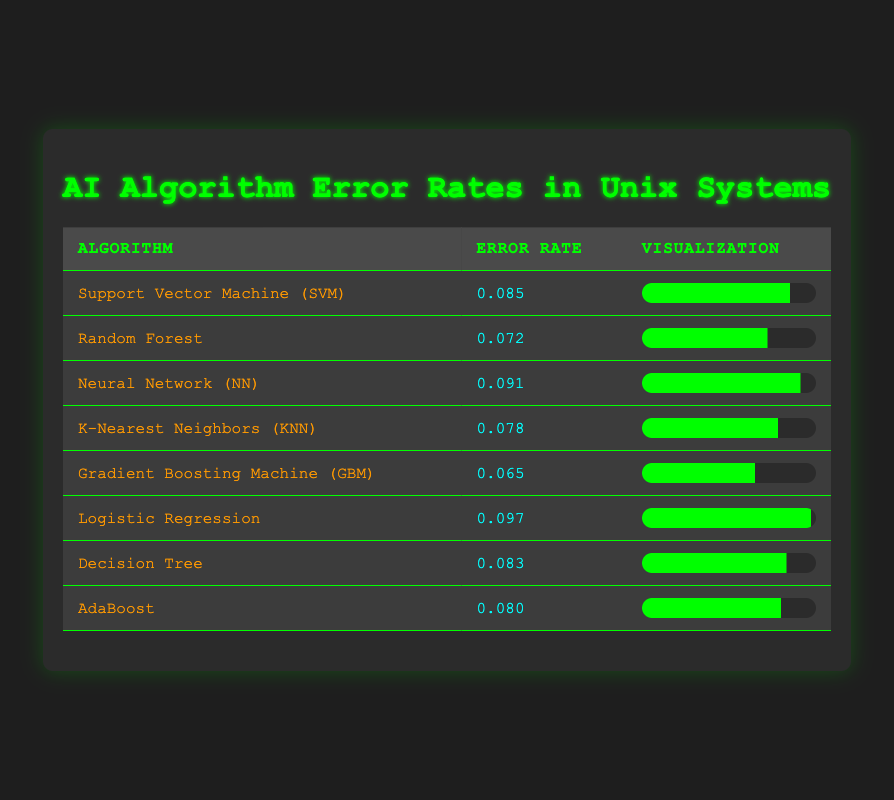What is the error rate of the Random Forest algorithm? The Random Forest algorithm is listed in the table along with its corresponding error rate, which is recorded as 0.072.
Answer: 0.072 Which algorithm has the highest error rate? By examining the error rates provided for all algorithms, the Logistic Regression algorithm has the highest error rate of 0.097.
Answer: 0.097 What is the average error rate of the algorithms listed? To find the average, sum all the error rates: (0.085 + 0.072 + 0.091 + 0.078 + 0.065 + 0.097 + 0.083 + 0.080) = 0.651. There are 8 algorithms, so the average error rate is 0.651 / 8 = 0.081375, which can be rounded to 0.081.
Answer: 0.081 Does the Decision Tree algorithm have a higher error rate than K-Nearest Neighbors? The Decision Tree error rate is 0.083 and the K-Nearest Neighbors error rate is 0.078. Since 0.083 is greater than 0.078, the Decision Tree does have a higher error rate.
Answer: Yes What is the error rate difference between the Gradient Boosting Machine and the Neural Network? The error rate of the Gradient Boosting Machine is 0.065 and the Neural Network is 0.091. The difference is calculated as 0.091 - 0.065 = 0.026.
Answer: 0.026 